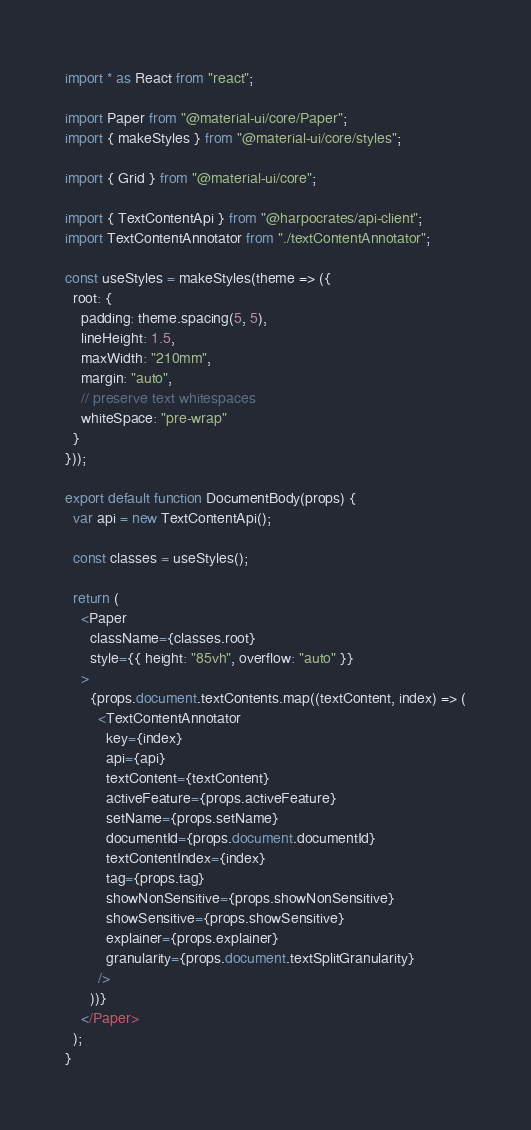<code> <loc_0><loc_0><loc_500><loc_500><_JavaScript_>import * as React from "react";

import Paper from "@material-ui/core/Paper";
import { makeStyles } from "@material-ui/core/styles";

import { Grid } from "@material-ui/core";

import { TextContentApi } from "@harpocrates/api-client";
import TextContentAnnotator from "./textContentAnnotator";

const useStyles = makeStyles(theme => ({
  root: {
    padding: theme.spacing(5, 5),
    lineHeight: 1.5,
    maxWidth: "210mm",
    margin: "auto",
    // preserve text whitespaces
    whiteSpace: "pre-wrap"
  }
}));

export default function DocumentBody(props) {
  var api = new TextContentApi();

  const classes = useStyles();

  return (
    <Paper
      className={classes.root}
      style={{ height: "85vh", overflow: "auto" }}
    >
      {props.document.textContents.map((textContent, index) => (
        <TextContentAnnotator
          key={index}
          api={api}
          textContent={textContent}
          activeFeature={props.activeFeature}
          setName={props.setName}
          documentId={props.document.documentId}
          textContentIndex={index}
          tag={props.tag}
          showNonSensitive={props.showNonSensitive}
          showSensitive={props.showSensitive}
          explainer={props.explainer}
          granularity={props.document.textSplitGranularity}
        />
      ))}
    </Paper>
  );
}
</code> 